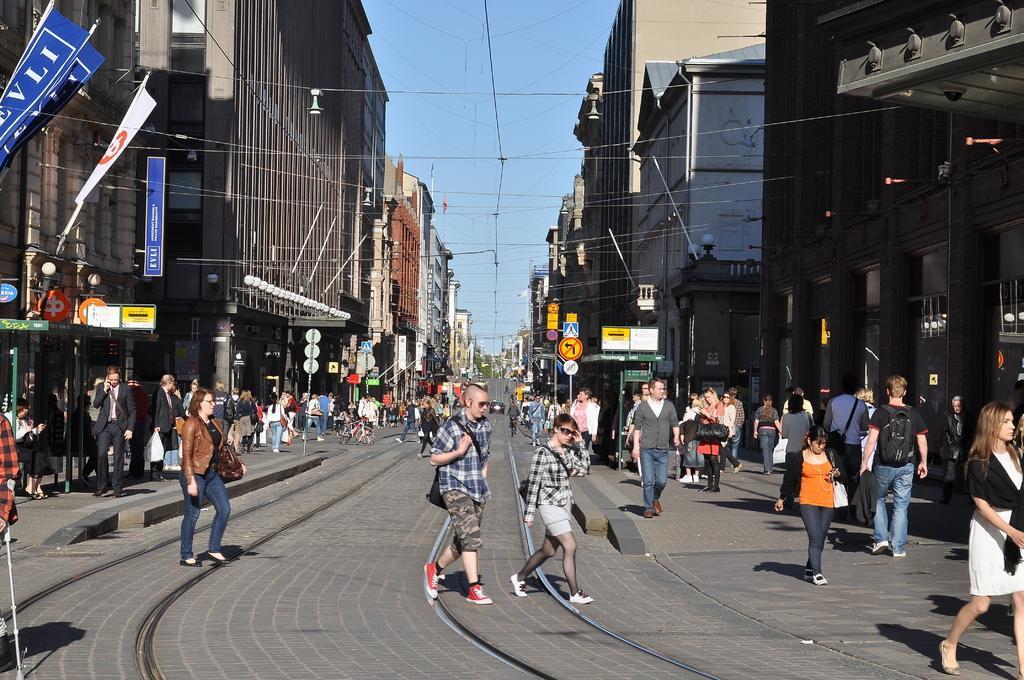In one or two sentences, can you explain what this image depicts? In this picture, we can see a few buildings, with lights, flags, posters, and we can see the road, a few people, rail track, posters, poles, sign boards, and the sky. 